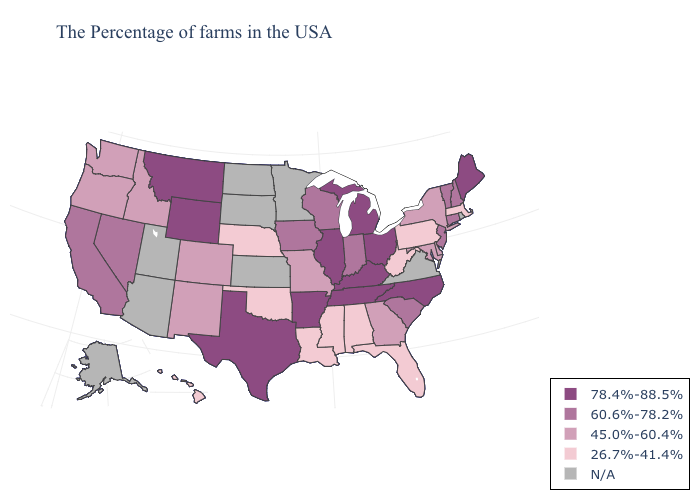What is the highest value in states that border South Carolina?
Quick response, please. 78.4%-88.5%. Name the states that have a value in the range 78.4%-88.5%?
Answer briefly. Maine, North Carolina, Ohio, Michigan, Kentucky, Tennessee, Illinois, Arkansas, Texas, Wyoming, Montana. Does Wyoming have the lowest value in the USA?
Quick response, please. No. Among the states that border Georgia , does North Carolina have the lowest value?
Quick response, please. No. Does the map have missing data?
Answer briefly. Yes. Name the states that have a value in the range 78.4%-88.5%?
Write a very short answer. Maine, North Carolina, Ohio, Michigan, Kentucky, Tennessee, Illinois, Arkansas, Texas, Wyoming, Montana. Among the states that border Colorado , does Nebraska have the lowest value?
Quick response, please. Yes. What is the highest value in the South ?
Quick response, please. 78.4%-88.5%. Does the map have missing data?
Be succinct. Yes. What is the lowest value in the USA?
Quick response, please. 26.7%-41.4%. Does the first symbol in the legend represent the smallest category?
Write a very short answer. No. Among the states that border Connecticut , which have the highest value?
Write a very short answer. New York. How many symbols are there in the legend?
Give a very brief answer. 5. Among the states that border Vermont , does New Hampshire have the highest value?
Short answer required. Yes. How many symbols are there in the legend?
Answer briefly. 5. 